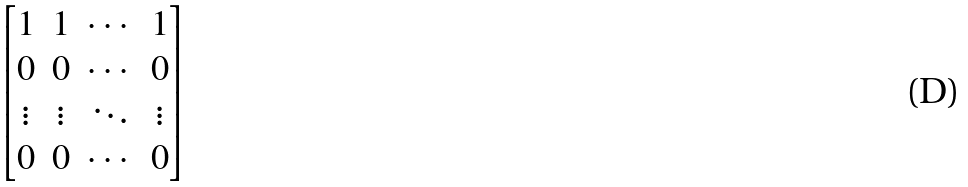<formula> <loc_0><loc_0><loc_500><loc_500>\begin{bmatrix} 1 & 1 & \cdots & 1 \\ 0 & 0 & \cdots & 0 \\ \vdots & \vdots & \ddots & \vdots \\ 0 & 0 & \cdots & 0 \end{bmatrix}</formula> 